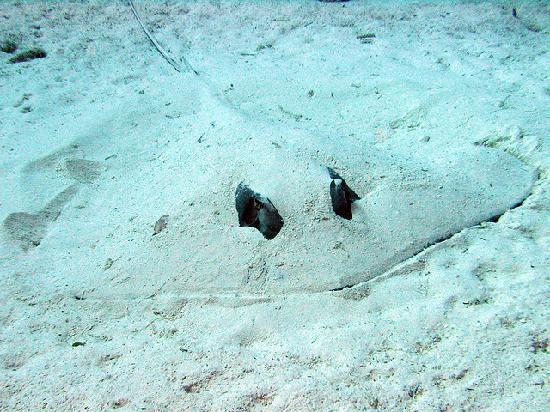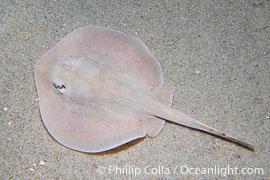The first image is the image on the left, the second image is the image on the right. Assess this claim about the two images: "All four of the skates are covered partially or nearly entirely by sand.". Correct or not? Answer yes or no. No. The first image is the image on the left, the second image is the image on the right. Assess this claim about the two images: "One image shows a camera-facing stingray mostly covered in sand, with black eyes projecting out.". Correct or not? Answer yes or no. Yes. 